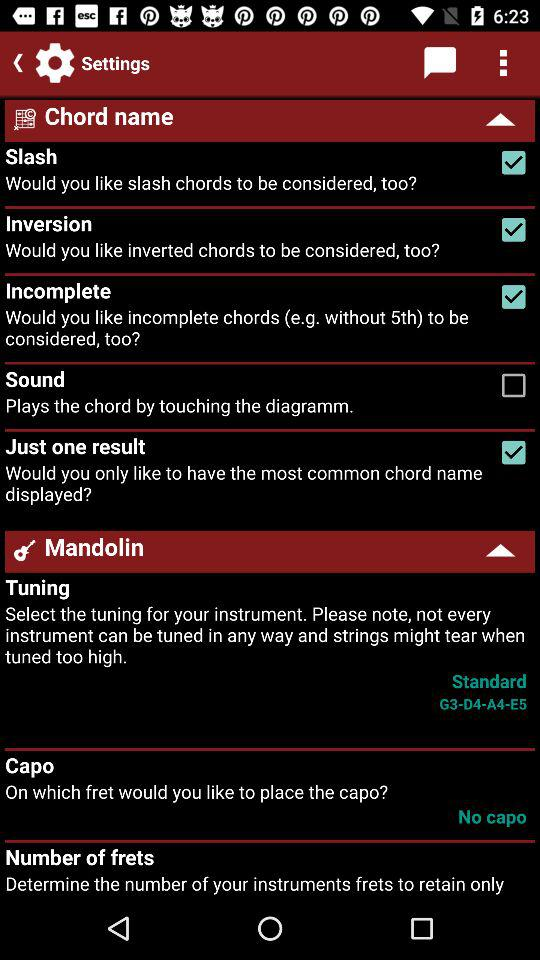Which option is not marked as checked? The option that is not marked as checked is "Sound". 